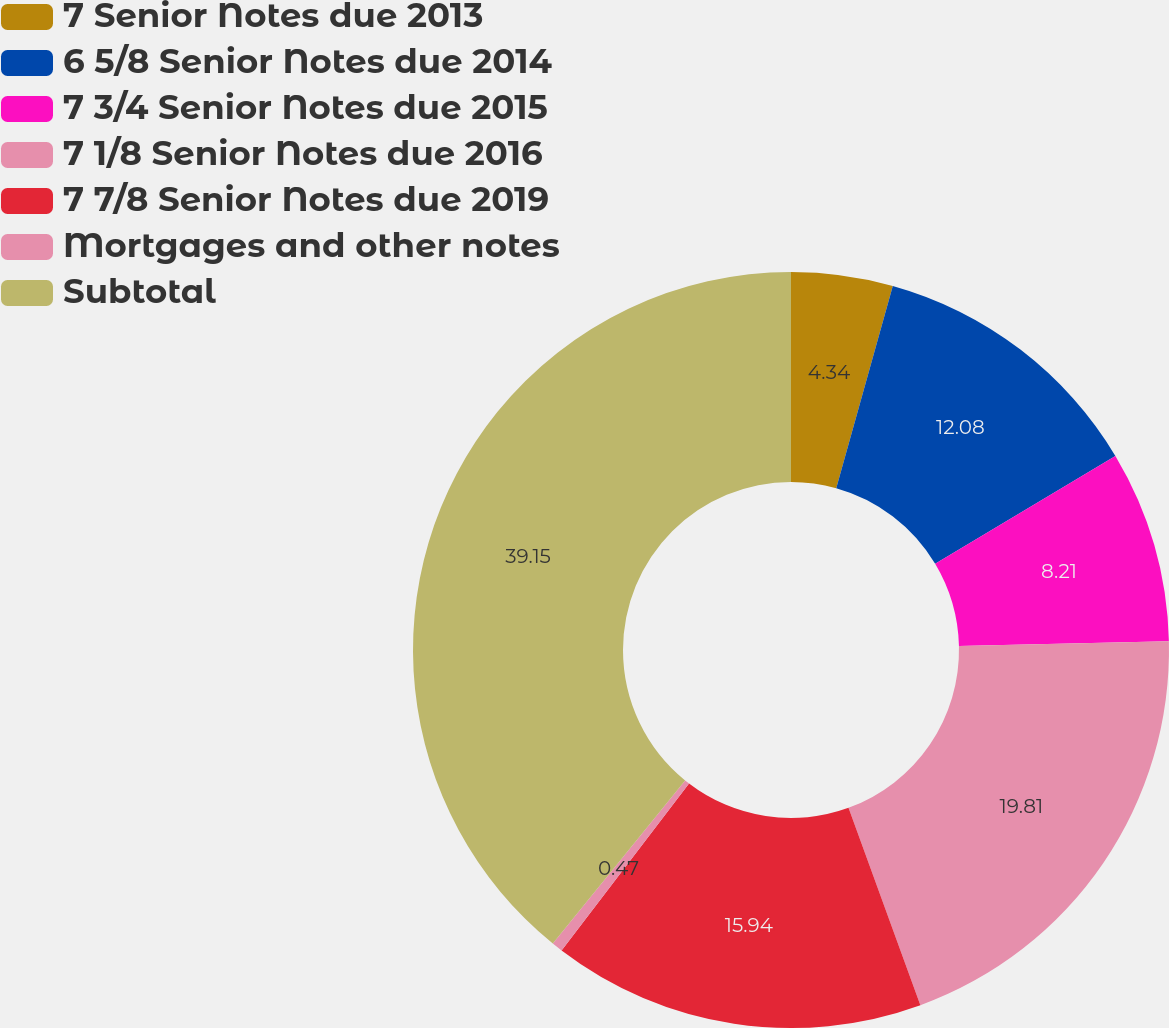Convert chart to OTSL. <chart><loc_0><loc_0><loc_500><loc_500><pie_chart><fcel>7 Senior Notes due 2013<fcel>6 5/8 Senior Notes due 2014<fcel>7 3/4 Senior Notes due 2015<fcel>7 1/8 Senior Notes due 2016<fcel>7 7/8 Senior Notes due 2019<fcel>Mortgages and other notes<fcel>Subtotal<nl><fcel>4.34%<fcel>12.08%<fcel>8.21%<fcel>19.81%<fcel>15.94%<fcel>0.47%<fcel>39.15%<nl></chart> 